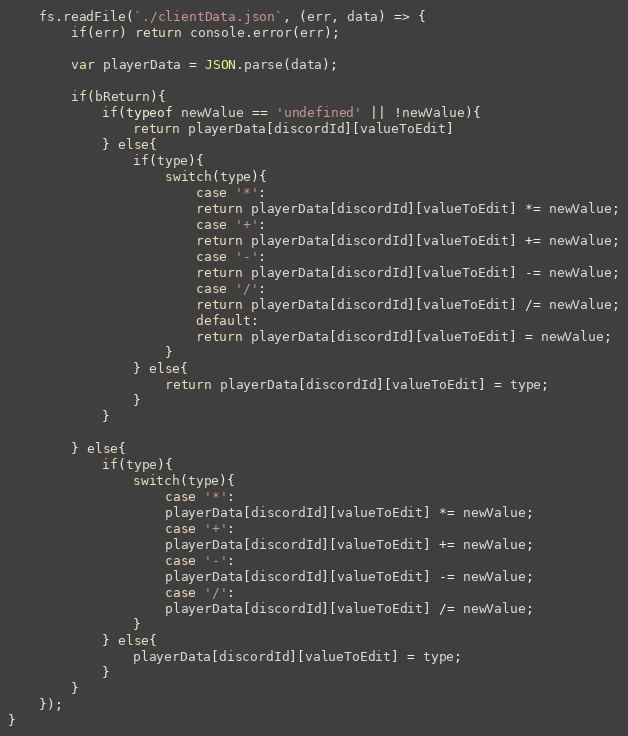<code> <loc_0><loc_0><loc_500><loc_500><_JavaScript_>    fs.readFile(`./clientData.json`, (err, data) => {
        if(err) return console.error(err);

        var playerData = JSON.parse(data);

        if(bReturn){
            if(typeof newValue == 'undefined' || !newValue){
                return playerData[discordId][valueToEdit]
            } else{
                if(type){
                    switch(type){
                        case '*':
                        return playerData[discordId][valueToEdit] *= newValue;
                        case '+':
                        return playerData[discordId][valueToEdit] += newValue;
                        case '-':
                        return playerData[discordId][valueToEdit] -= newValue;
                        case '/':
                        return playerData[discordId][valueToEdit] /= newValue;
                        default:
                        return playerData[discordId][valueToEdit] = newValue;
                    }
                } else{
                    return playerData[discordId][valueToEdit] = type;
                }
            }

        } else{
            if(type){
                switch(type){
                    case '*':
                    playerData[discordId][valueToEdit] *= newValue;
                    case '+':
                    playerData[discordId][valueToEdit] += newValue;
                    case '-':
                    playerData[discordId][valueToEdit] -= newValue;
                    case '/':
                    playerData[discordId][valueToEdit] /= newValue;
                }
            } else{
                playerData[discordId][valueToEdit] = type;
            }
        }
    });
}</code> 